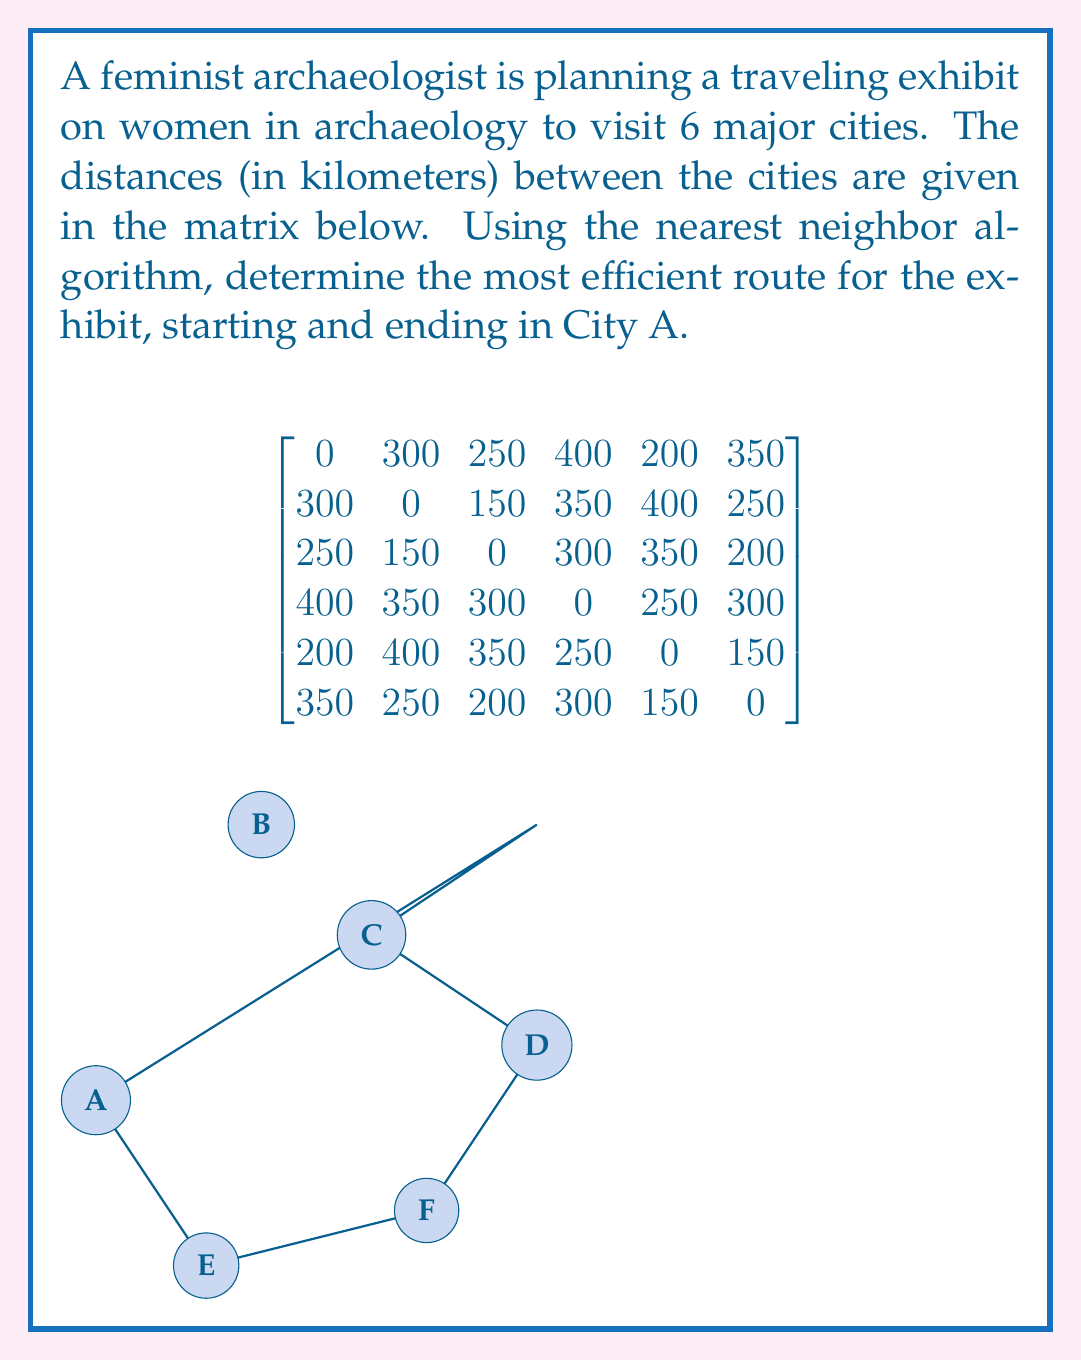Give your solution to this math problem. Let's apply the nearest neighbor algorithm step by step:

1. Start at City A:
   - Distances from A: B(300), C(250), D(400), E(200), F(350)
   - Nearest city is E (200 km)

2. Move to City E:
   - Distances from E: B(400), C(350), D(250), F(150)
   - Nearest city is F (150 km)

3. Move to City F:
   - Distances from F: B(250), C(200), D(300)
   - Nearest city is C (200 km)

4. Move to City C:
   - Distances from C: B(150), D(300)
   - Nearest city is B (150 km)

5. Move to City B:
   - Only D remains, distance is 350 km

6. Move to City D:
   - Return to A, distance is 400 km

The total route is: A → E → F → C → B → D → A

To calculate the total distance:
$$ \text{Total Distance} = 200 + 150 + 200 + 150 + 350 + 400 = 1450 \text{ km} $$
Answer: A → E → F → C → B → D → A; 1450 km 